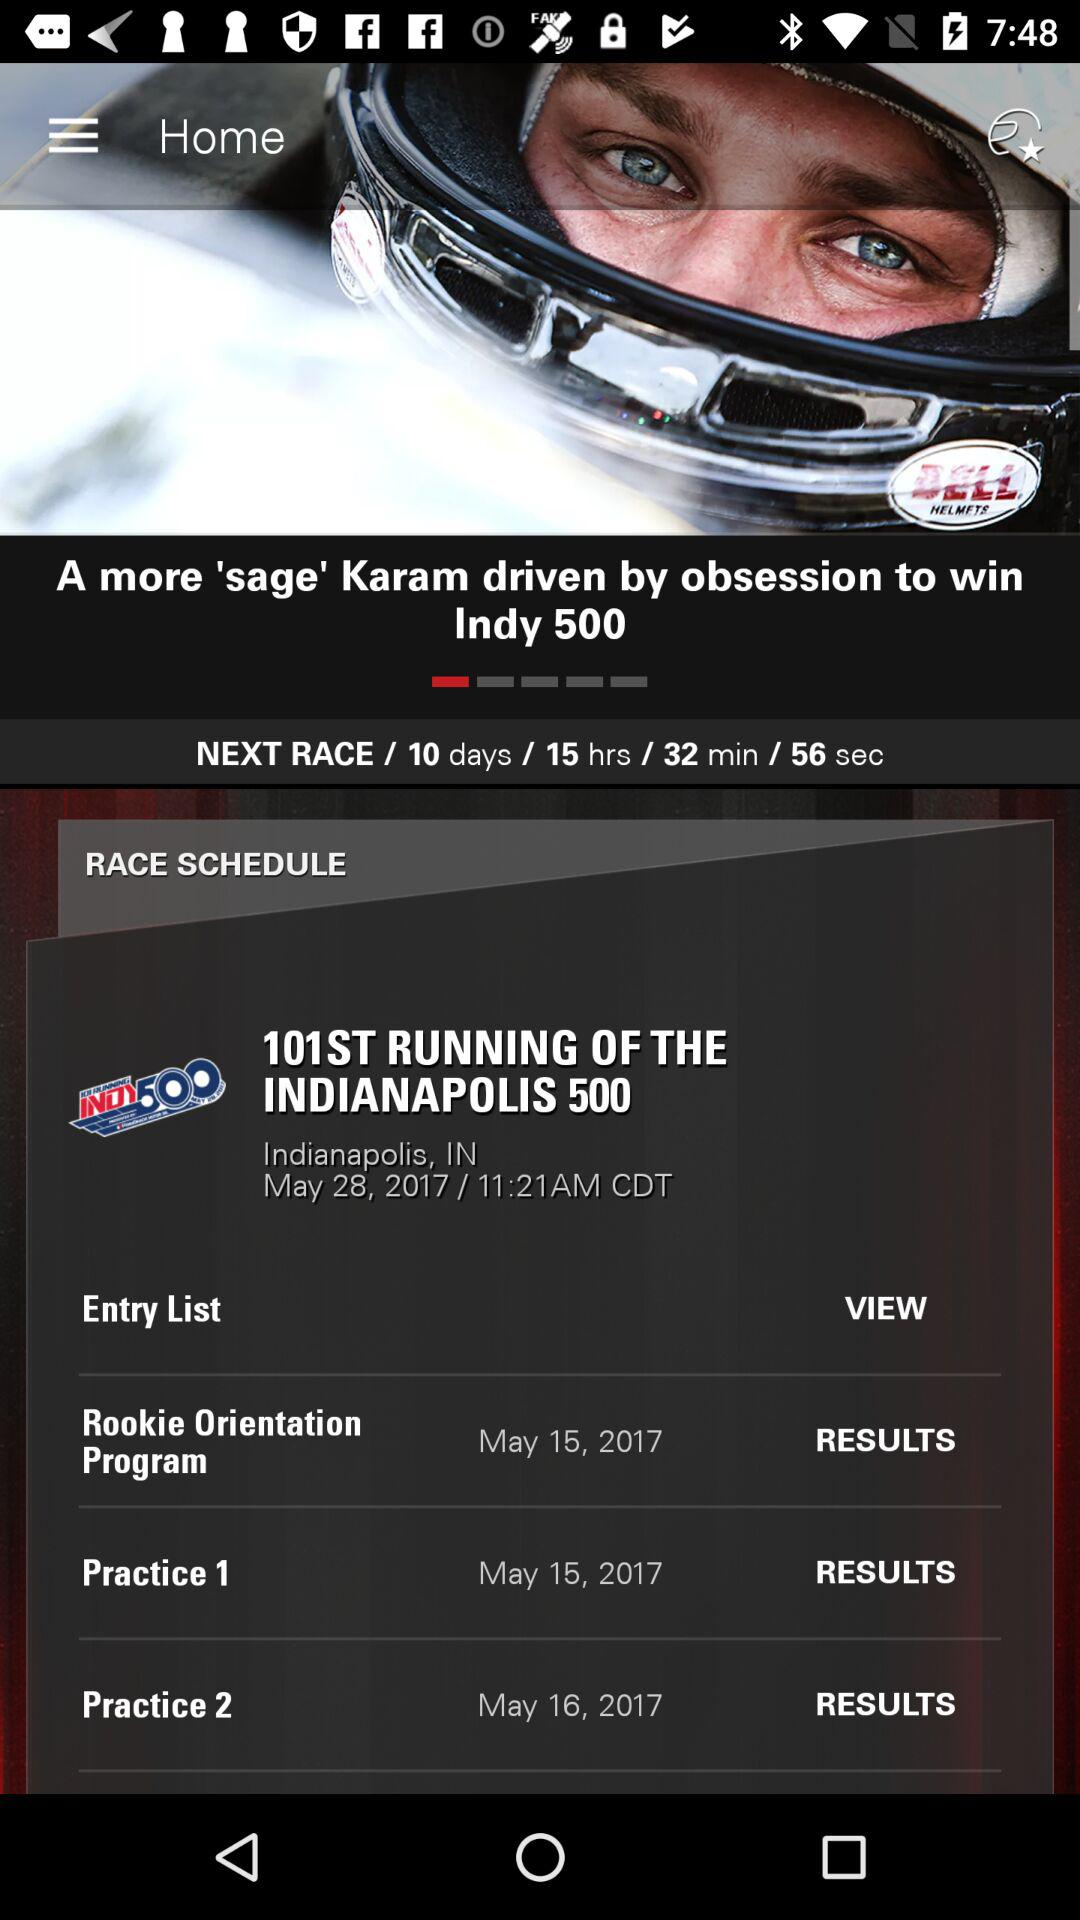Where will the 101st running of the Indianapolis 500 race happen? The race will happen in "Indianapolis, IN". 